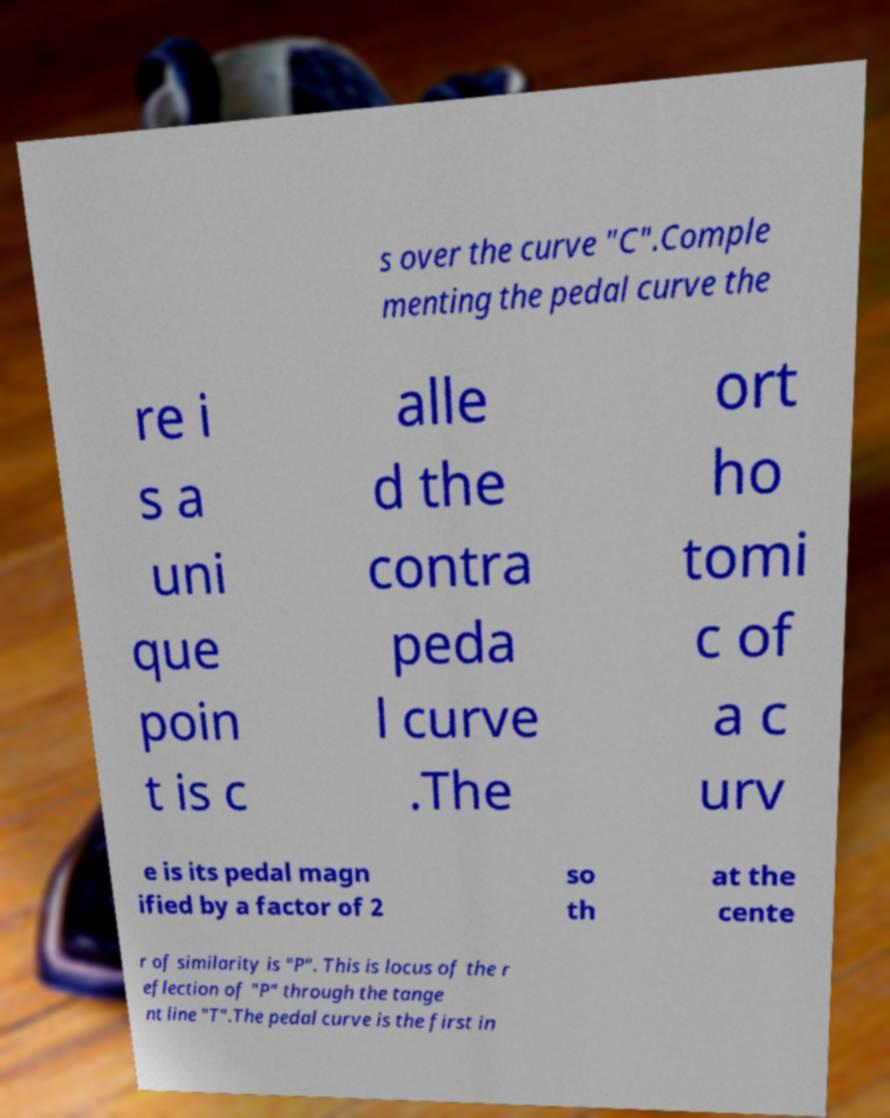I need the written content from this picture converted into text. Can you do that? s over the curve "C".Comple menting the pedal curve the re i s a uni que poin t is c alle d the contra peda l curve .The ort ho tomi c of a c urv e is its pedal magn ified by a factor of 2 so th at the cente r of similarity is "P". This is locus of the r eflection of "P" through the tange nt line "T".The pedal curve is the first in 